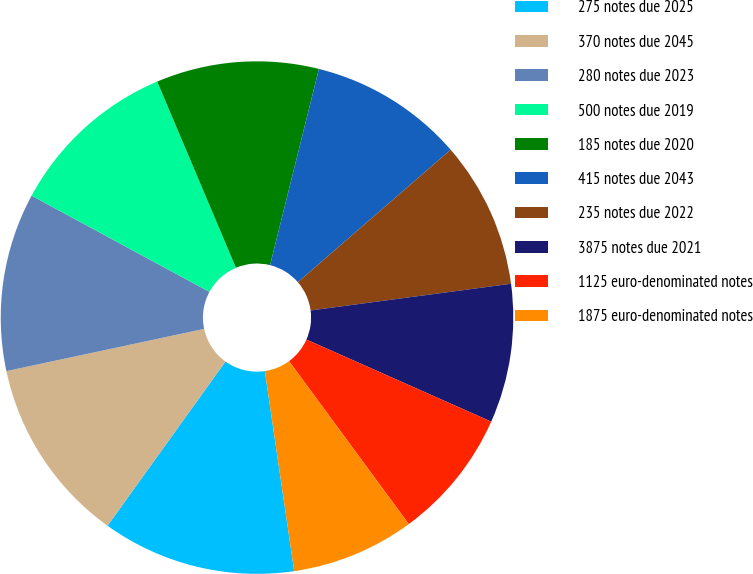Convert chart to OTSL. <chart><loc_0><loc_0><loc_500><loc_500><pie_chart><fcel>275 notes due 2025<fcel>370 notes due 2045<fcel>280 notes due 2023<fcel>500 notes due 2019<fcel>185 notes due 2020<fcel>415 notes due 2043<fcel>235 notes due 2022<fcel>3875 notes due 2021<fcel>1125 euro-denominated notes<fcel>1875 euro-denominated notes<nl><fcel>12.23%<fcel>11.74%<fcel>11.24%<fcel>10.74%<fcel>10.25%<fcel>9.75%<fcel>9.26%<fcel>8.76%<fcel>8.26%<fcel>7.77%<nl></chart> 